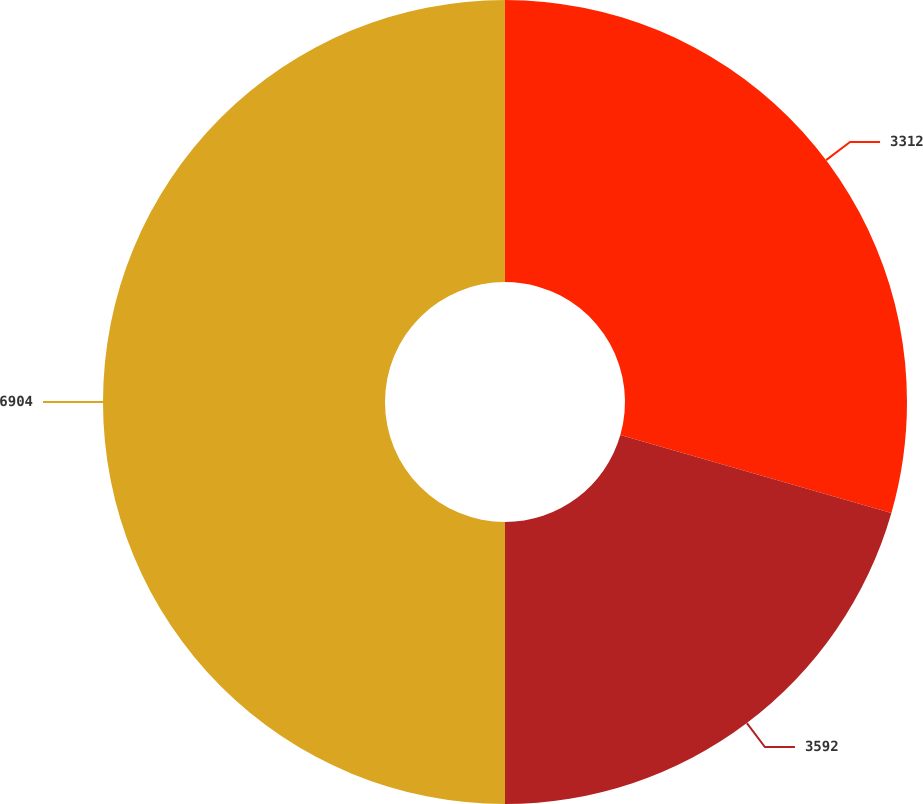<chart> <loc_0><loc_0><loc_500><loc_500><pie_chart><fcel>3312<fcel>3592<fcel>6904<nl><fcel>29.45%<fcel>20.55%<fcel>50.0%<nl></chart> 